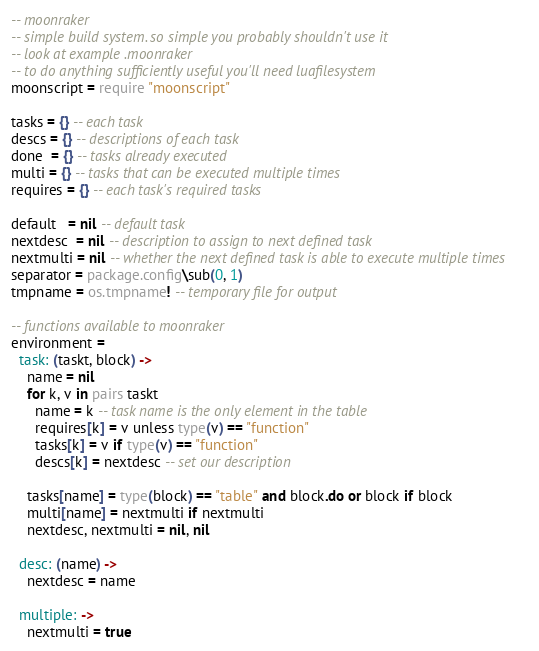Convert code to text. <code><loc_0><loc_0><loc_500><loc_500><_MoonScript_>-- moonraker
-- simple build system. so simple you probably shouldn't use it
-- look at example .moonraker
-- to do anything sufficiently useful you'll need luafilesystem
moonscript = require "moonscript"

tasks = {} -- each task
descs = {} -- descriptions of each task
done  = {} -- tasks already executed
multi = {} -- tasks that can be executed multiple times
requires = {} -- each task's required tasks

default   = nil -- default task
nextdesc  = nil -- description to assign to next defined task
nextmulti = nil -- whether the next defined task is able to execute multiple times
separator = package.config\sub(0, 1)
tmpname = os.tmpname! -- temporary file for output

-- functions available to moonraker
environment =
  task: (taskt, block) ->
    name = nil
    for k, v in pairs taskt
      name = k -- task name is the only element in the table
      requires[k] = v unless type(v) == "function"
      tasks[k] = v if type(v) == "function"
      descs[k] = nextdesc -- set our description

    tasks[name] = type(block) == "table" and block.do or block if block
    multi[name] = nextmulti if nextmulti
    nextdesc, nextmulti = nil, nil

  desc: (name) ->
    nextdesc = name

  multiple: ->
    nextmulti = true
</code> 